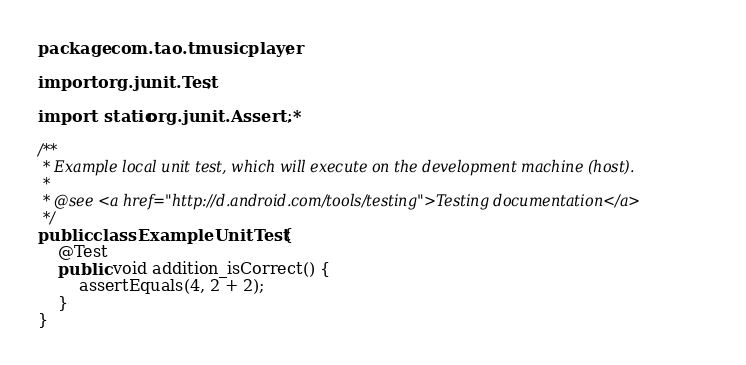Convert code to text. <code><loc_0><loc_0><loc_500><loc_500><_Java_>package com.tao.tmusicplayer;

import org.junit.Test;

import static org.junit.Assert.*;

/**
 * Example local unit test, which will execute on the development machine (host).
 *
 * @see <a href="http://d.android.com/tools/testing">Testing documentation</a>
 */
public class ExampleUnitTest {
    @Test
    public void addition_isCorrect() {
        assertEquals(4, 2 + 2);
    }
}</code> 